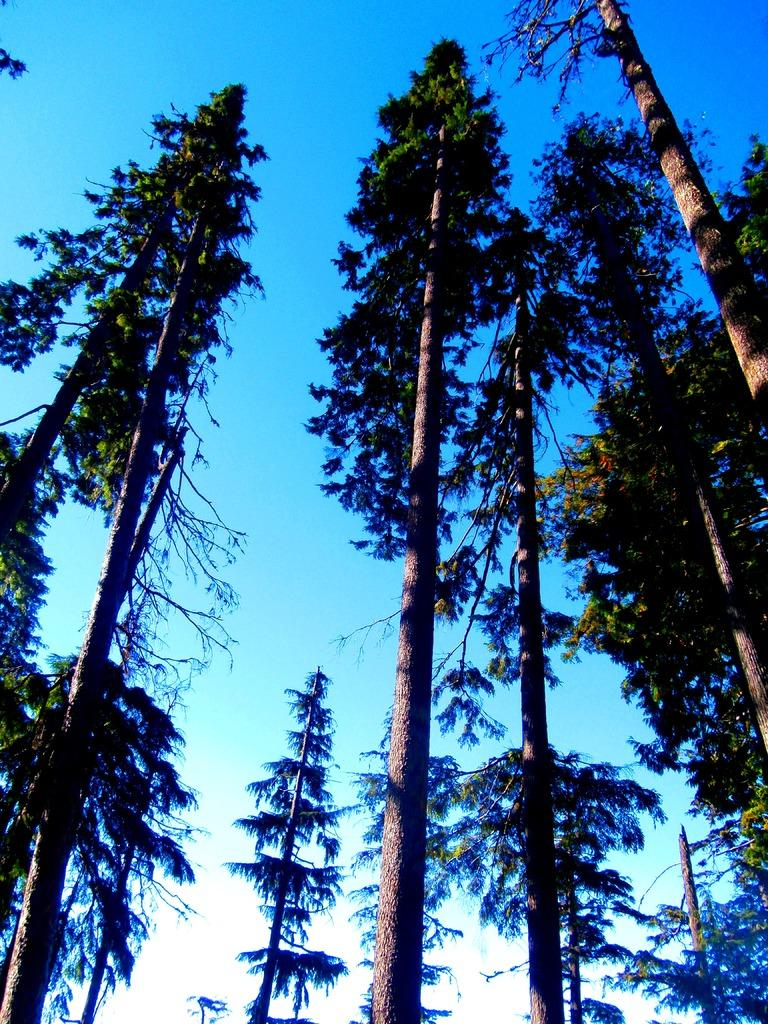What type of vegetation can be seen in the image? There are trees in the image. What part of the natural environment is visible in the image? The sky is visible in the background of the image. What type of berry is being picked by the girls in the image? There are no girls or berries present in the image; it only features trees and the sky. 